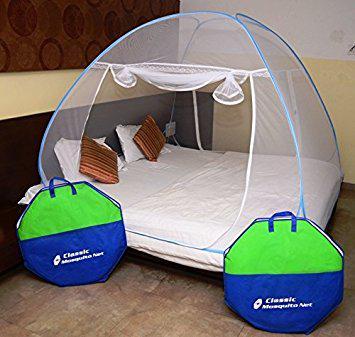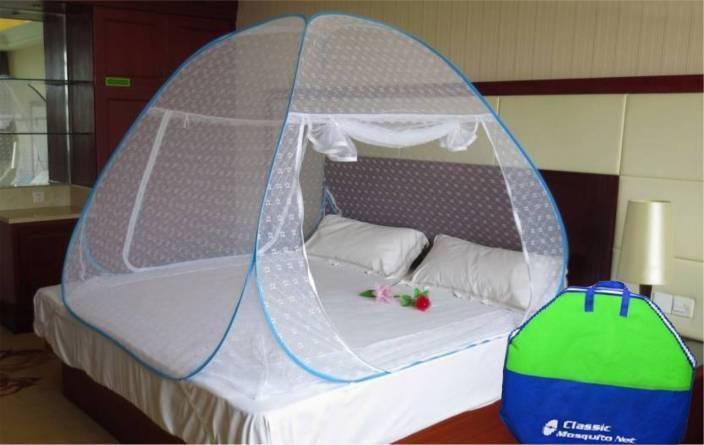The first image is the image on the left, the second image is the image on the right. For the images shown, is this caption "In at least one image, a green and blue case sits in front of a bed canopy." true? Answer yes or no. Yes. The first image is the image on the left, the second image is the image on the right. For the images shown, is this caption "there are two brown pillows in the image on the left" true? Answer yes or no. Yes. 